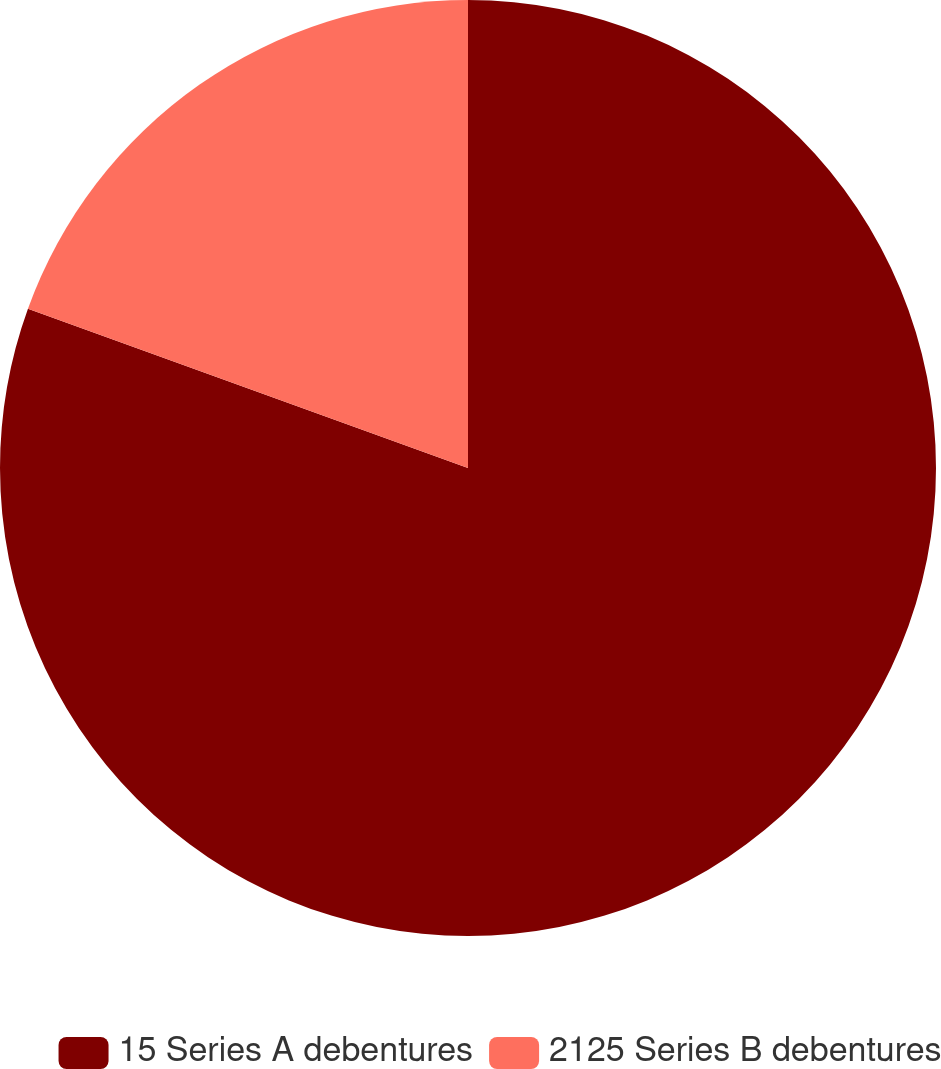<chart> <loc_0><loc_0><loc_500><loc_500><pie_chart><fcel>15 Series A debentures<fcel>2125 Series B debentures<nl><fcel>80.53%<fcel>19.47%<nl></chart> 